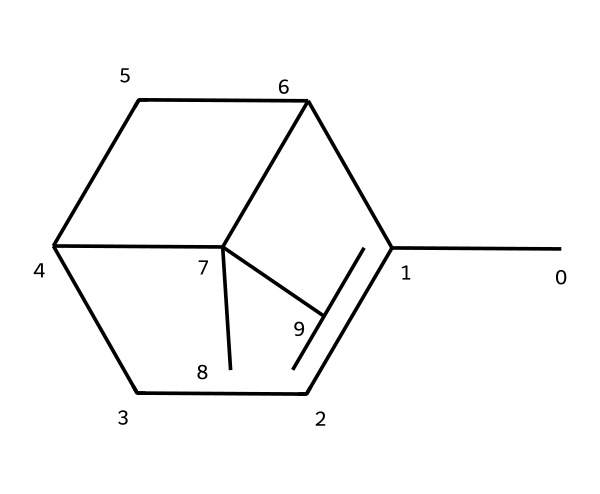How many carbon atoms are in this molecule? Counting the carbon atoms represented in the SMILES notation, we can identify that there are a total of 10 carbon atoms present in the molecular structure.
Answer: 10 What type of cyclic structure does pinene have? Analyzing the SMILES structure, it shows that pinene contains two interconnected cyclohexane rings, indicating a bicyclic structure formation.
Answer: bicyclic What is the molecular formula of pinene? To determine the molecular formula, we aggregate the counts of carbon and hydrogen atoms from the structure: 10 carbons and 16 hydrogens, giving us the formula C10H16.
Answer: C10H16 Which feature indicates that this compound is a terpene? This compound has multiple double bonds and a specific arrangement of carbon atoms, which aligns with the functional characteristics of terpenes, specifically that its structure is built from isoprene units.
Answer: isoprene units How many double bonds are present in this molecule? By closely examining the molecular structure depicted in the SMILES, we can spot two pi bonds, indicating the presence of 2 double bonds in the pinene structure.
Answer: 2 What characteristic functional group is prominent in pinene? The presence of a double bond in the structure suggests it is classified among alkenes, which is typical for terpenes like pinene, where these unsaturation points are key.
Answer: alkene 